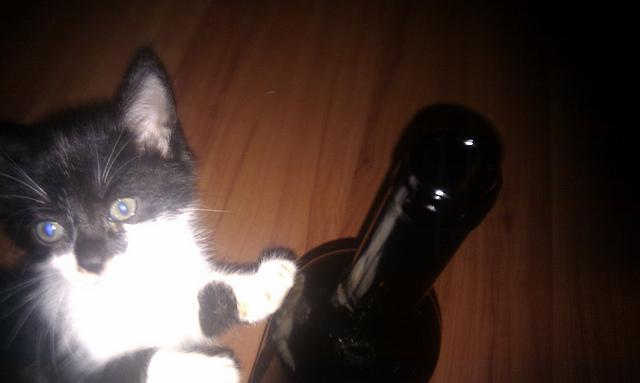What is the cat trying to drink?
Give a very brief answer. Wine. What colors is the kitty?
Quick response, please. Black and white. What has a black top?
Give a very brief answer. Bottle. Is this an adult cat?
Write a very short answer. No. 